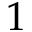Convert formula to latex. <formula><loc_0><loc_0><loc_500><loc_500>1</formula> 